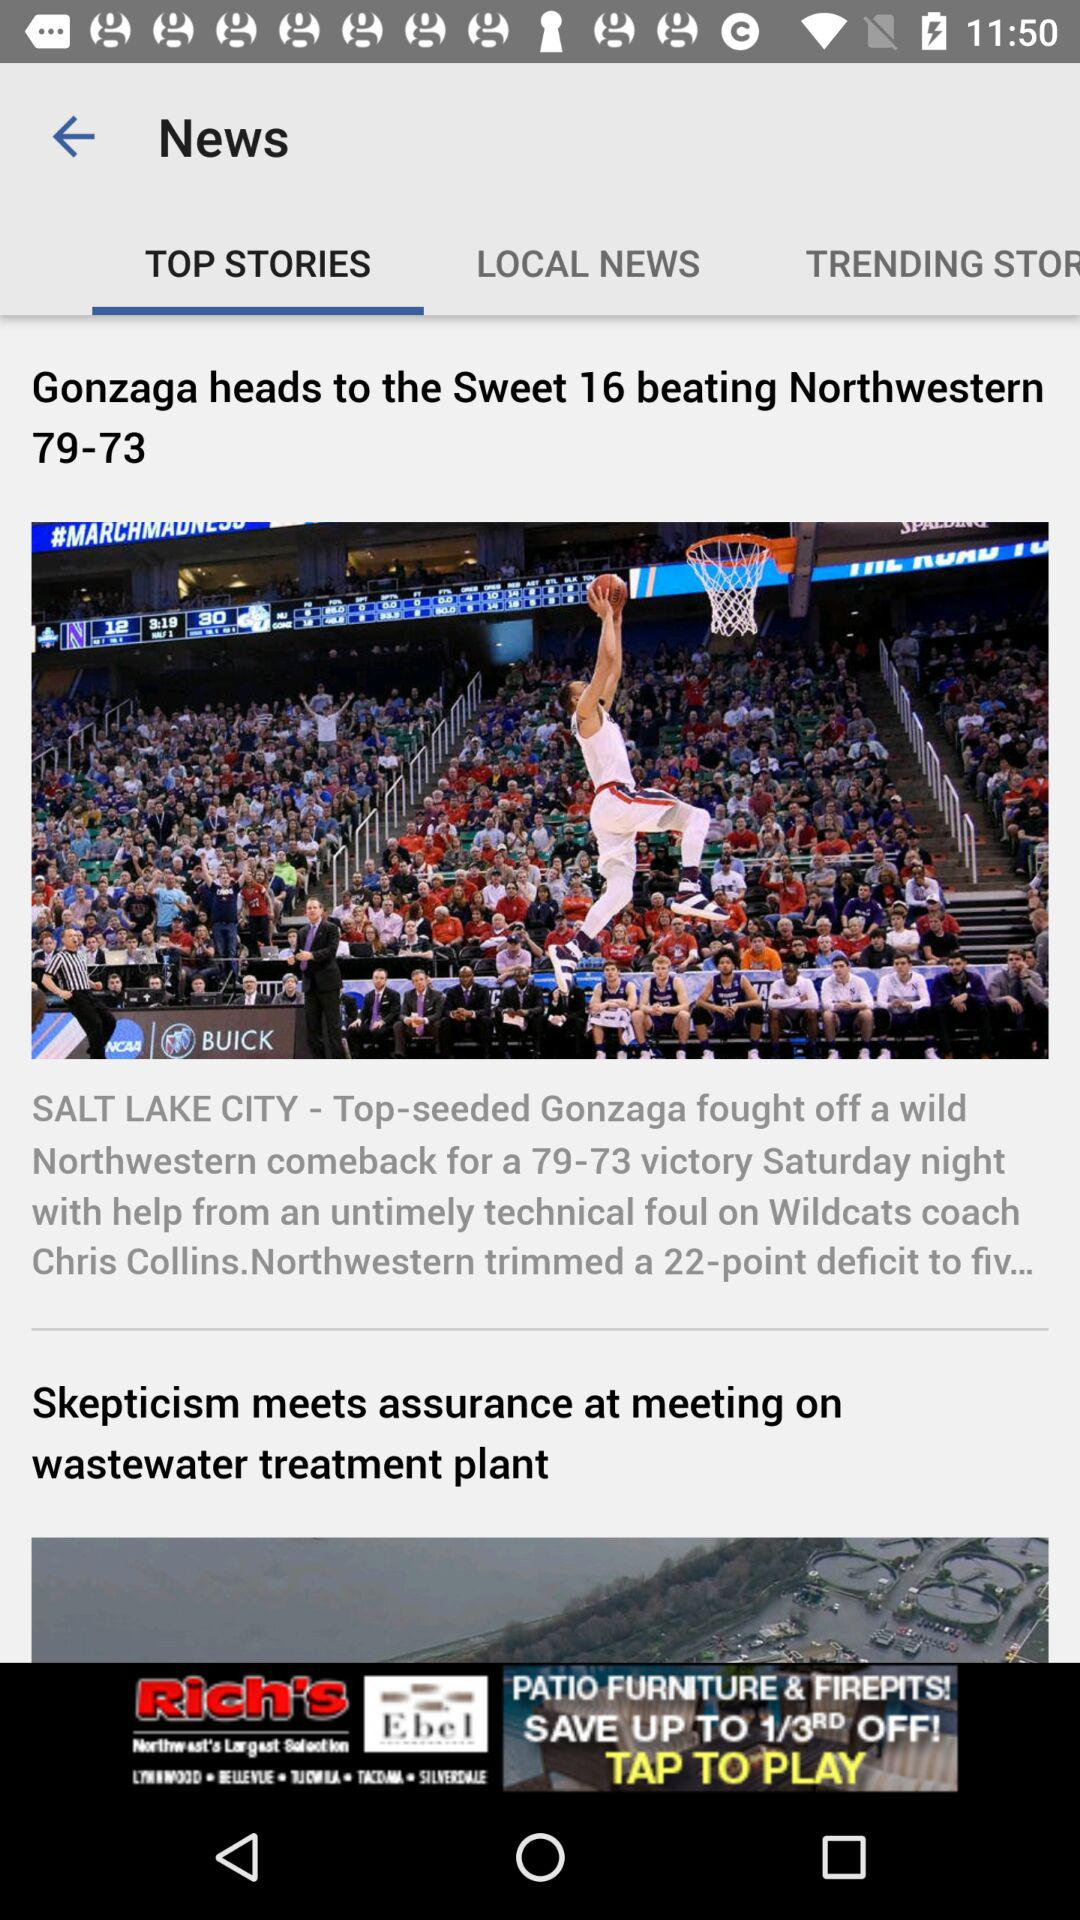Which tab is selected? The selected tab is "TOP STORIES". 